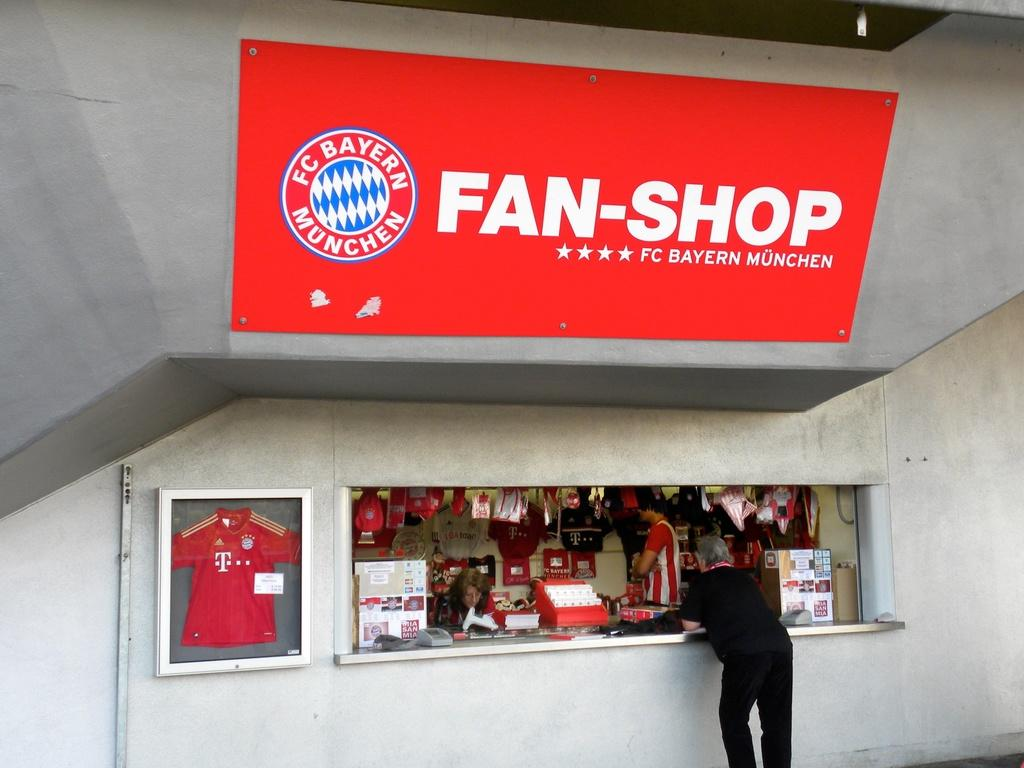<image>
Render a clear and concise summary of the photo. A person standing at an order counter with a Fan-Shop sign above him. 